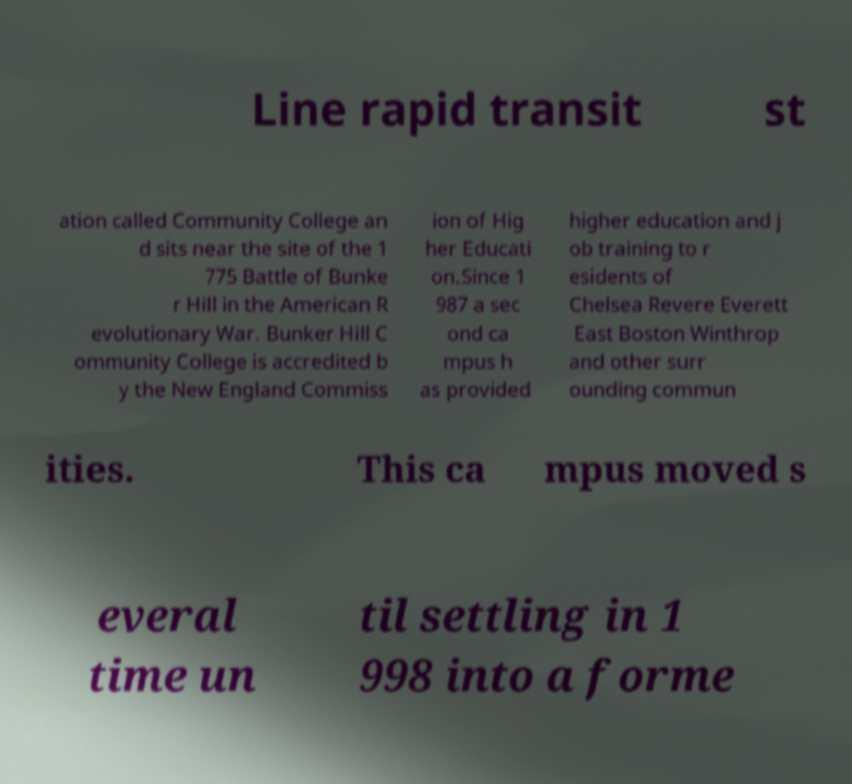Could you assist in decoding the text presented in this image and type it out clearly? Line rapid transit st ation called Community College an d sits near the site of the 1 775 Battle of Bunke r Hill in the American R evolutionary War. Bunker Hill C ommunity College is accredited b y the New England Commiss ion of Hig her Educati on.Since 1 987 a sec ond ca mpus h as provided higher education and j ob training to r esidents of Chelsea Revere Everett East Boston Winthrop and other surr ounding commun ities. This ca mpus moved s everal time un til settling in 1 998 into a forme 